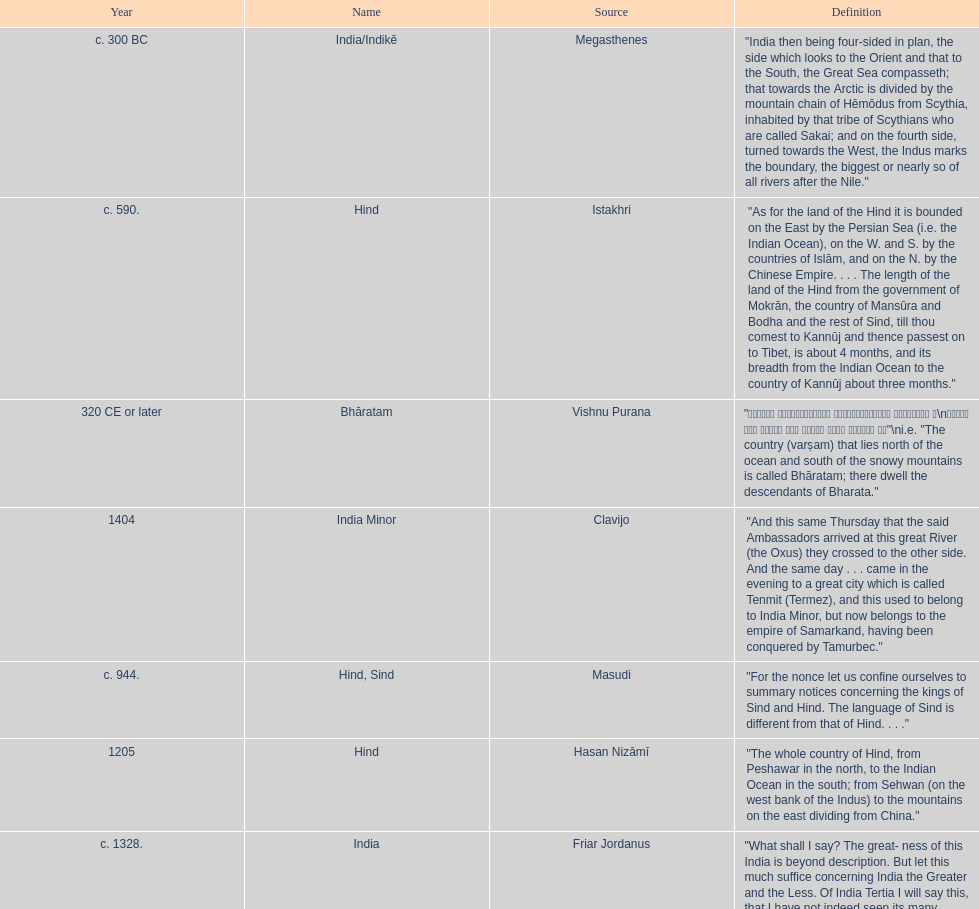Which is the most recent source for the name? Clavijo. 